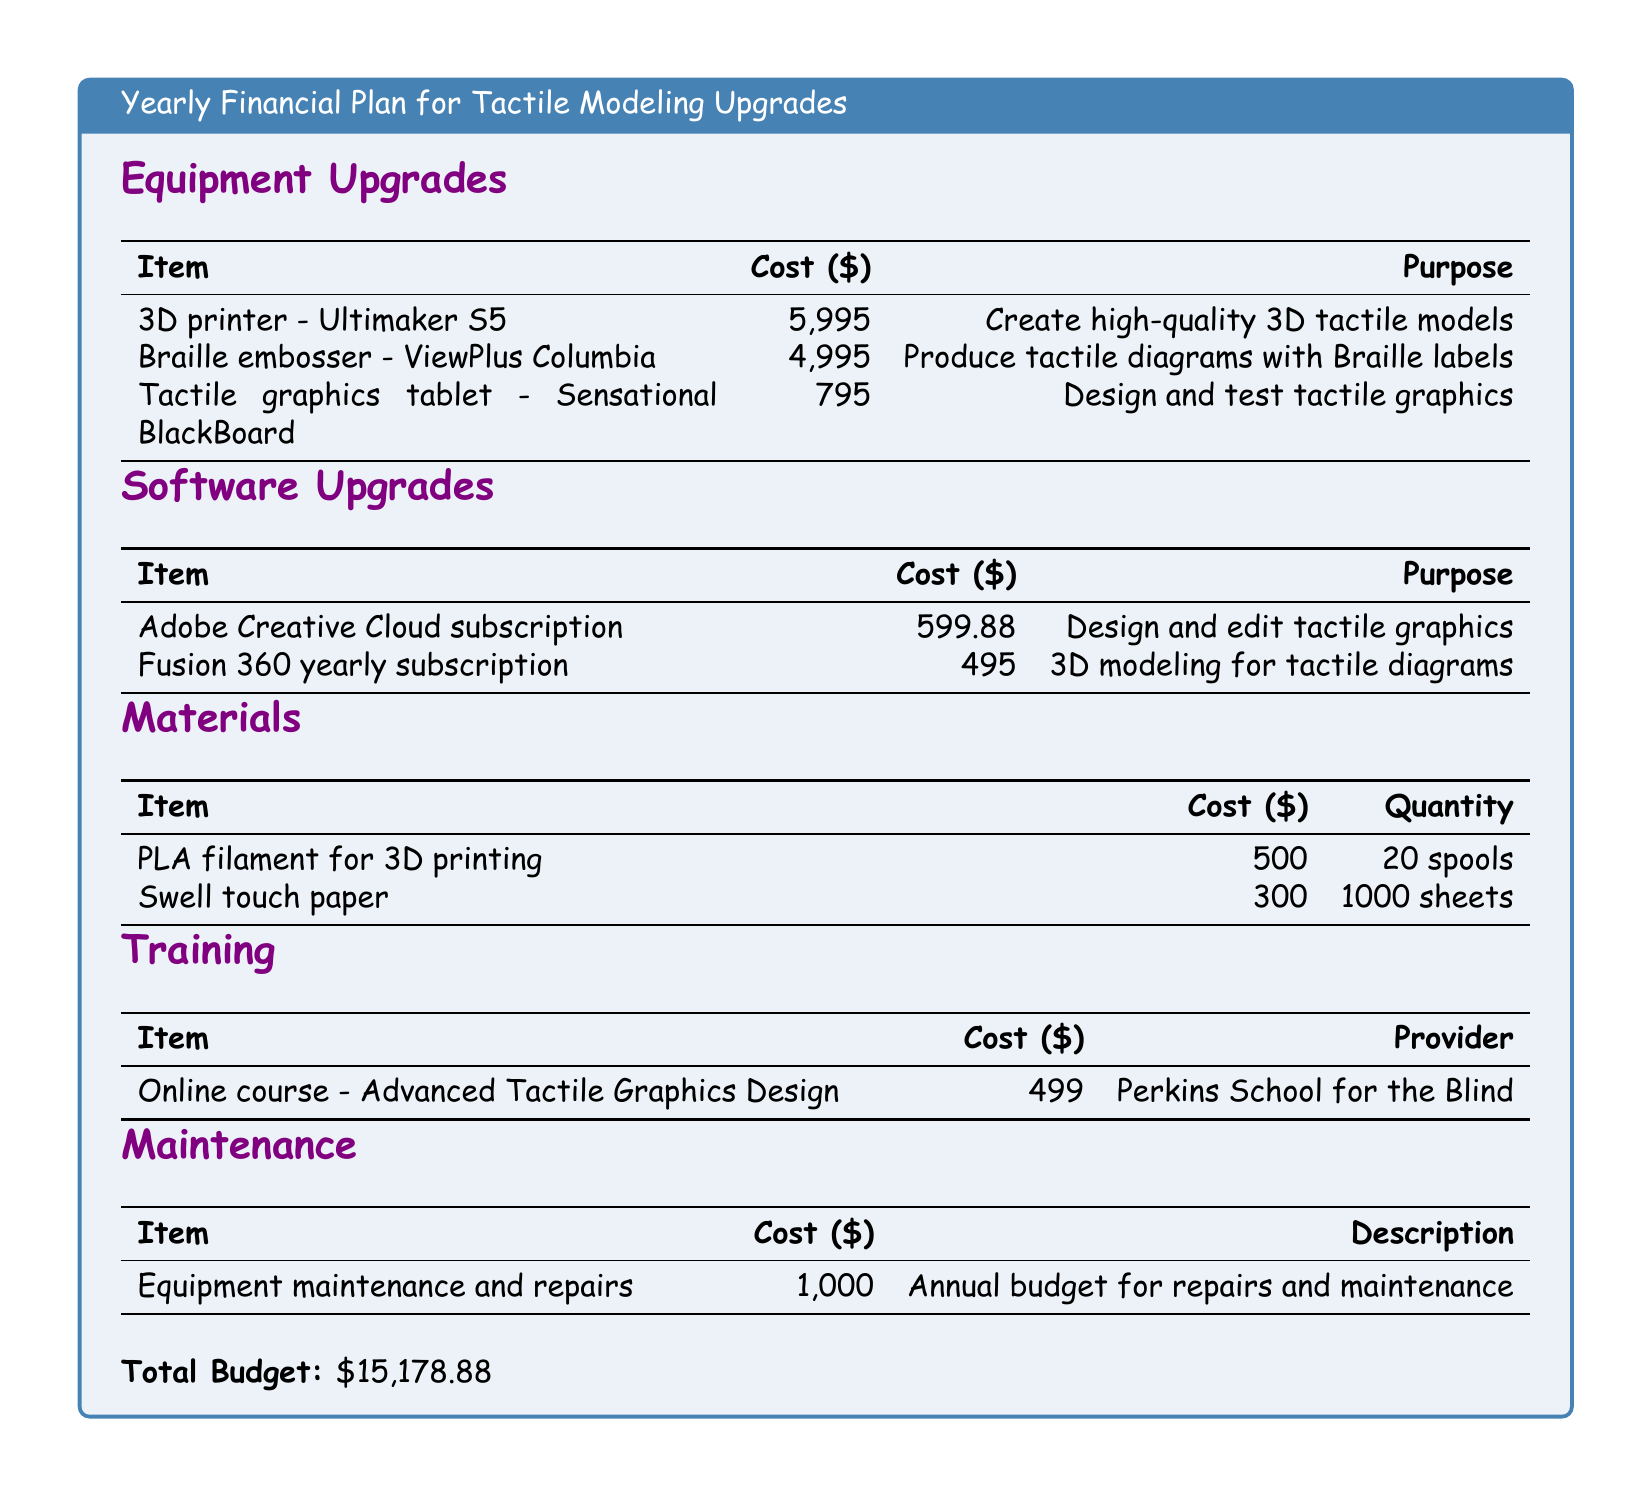what is the total budget? The total budget is the sum of all costs listed in the document, which is $5,995 + $4,995 + $795 + $599.88 + $495 + $500 + $300 + $499 + $1,000 = $15,178.88.
Answer: $15,178.88 how much does the Braille embosser cost? The cost of the Braille embosser - ViewPlus Columbia is specifically listed as $4,995 in the document.
Answer: $4,995 what is the purpose of the Adobe Creative Cloud subscription? The document states that the purpose of the Adobe Creative Cloud subscription is to design and edit tactile graphics.
Answer: Design and edit tactile graphics how many spools of PLA filament are included in the materials? The document specifies that there are 20 spools of PLA filament for 3D printing included in the materials section.
Answer: 20 spools which provider offers the online course for tactile graphics design? According to the document, Perkins School for the Blind is the provider for the online course - Advanced Tactile Graphics Design.
Answer: Perkins School for the Blind what is the total cost of equipment upgrades? The total cost of equipment upgrades is calculated by adding the costs of each item in that section: $5,995 + $4,995 + $795 = $11,785.
Answer: $11,785 how much does the Fusion 360 yearly subscription cost? The document lists the cost of the Fusion 360 yearly subscription as $495.
Answer: $495 what is included in the maintenance budget? The document states that the maintenance budget includes annual equipment maintenance and repairs costing $1,000.
Answer: Annual budget for repairs and maintenance what type of printer is the Ultimaker S5? The document classifies the Ultimaker S5 as a 3D printer.
Answer: 3D printer 